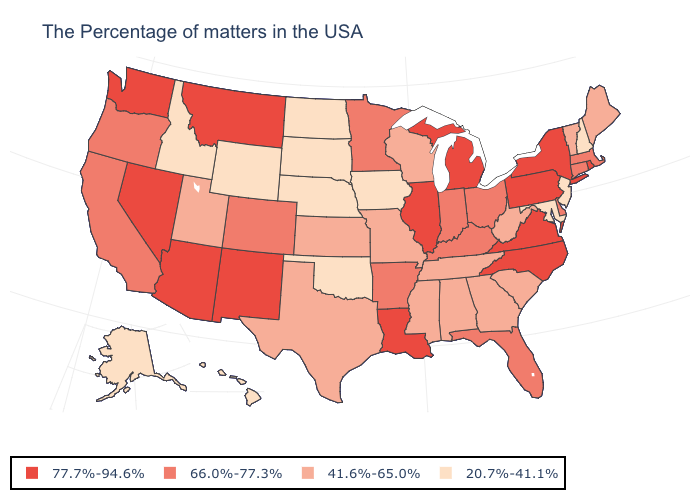Among the states that border Maryland , which have the lowest value?
Write a very short answer. West Virginia. What is the value of Kentucky?
Quick response, please. 66.0%-77.3%. Among the states that border Minnesota , does Iowa have the lowest value?
Write a very short answer. Yes. Does North Carolina have the highest value in the South?
Short answer required. Yes. Does Pennsylvania have the same value as Hawaii?
Answer briefly. No. Name the states that have a value in the range 66.0%-77.3%?
Concise answer only. Massachusetts, Connecticut, Delaware, Ohio, Florida, Kentucky, Indiana, Arkansas, Minnesota, Colorado, California, Oregon. Name the states that have a value in the range 66.0%-77.3%?
Concise answer only. Massachusetts, Connecticut, Delaware, Ohio, Florida, Kentucky, Indiana, Arkansas, Minnesota, Colorado, California, Oregon. What is the value of Ohio?
Short answer required. 66.0%-77.3%. Name the states that have a value in the range 20.7%-41.1%?
Keep it brief. New Hampshire, New Jersey, Maryland, Iowa, Nebraska, Oklahoma, South Dakota, North Dakota, Wyoming, Idaho, Alaska, Hawaii. Does Texas have the same value as Michigan?
Quick response, please. No. Does Nebraska have the lowest value in the USA?
Give a very brief answer. Yes. What is the lowest value in the USA?
Be succinct. 20.7%-41.1%. Does the map have missing data?
Give a very brief answer. No. What is the value of Texas?
Concise answer only. 41.6%-65.0%. What is the highest value in states that border West Virginia?
Give a very brief answer. 77.7%-94.6%. 